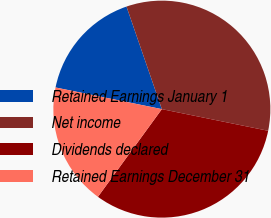Convert chart to OTSL. <chart><loc_0><loc_0><loc_500><loc_500><pie_chart><fcel>Retained Earnings January 1<fcel>Net income<fcel>Dividends declared<fcel>Retained Earnings December 31<nl><fcel>16.52%<fcel>33.48%<fcel>31.83%<fcel>18.17%<nl></chart> 